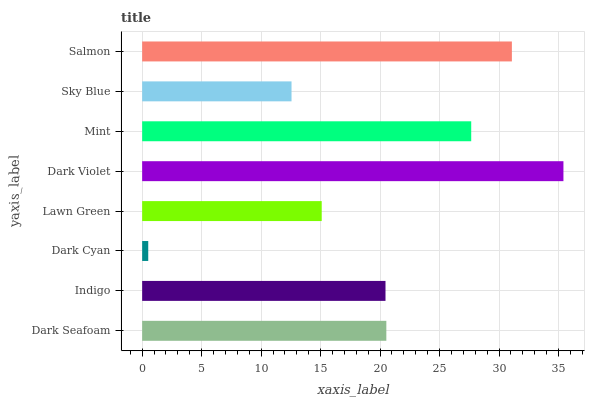Is Dark Cyan the minimum?
Answer yes or no. Yes. Is Dark Violet the maximum?
Answer yes or no. Yes. Is Indigo the minimum?
Answer yes or no. No. Is Indigo the maximum?
Answer yes or no. No. Is Dark Seafoam greater than Indigo?
Answer yes or no. Yes. Is Indigo less than Dark Seafoam?
Answer yes or no. Yes. Is Indigo greater than Dark Seafoam?
Answer yes or no. No. Is Dark Seafoam less than Indigo?
Answer yes or no. No. Is Dark Seafoam the high median?
Answer yes or no. Yes. Is Indigo the low median?
Answer yes or no. Yes. Is Sky Blue the high median?
Answer yes or no. No. Is Dark Violet the low median?
Answer yes or no. No. 